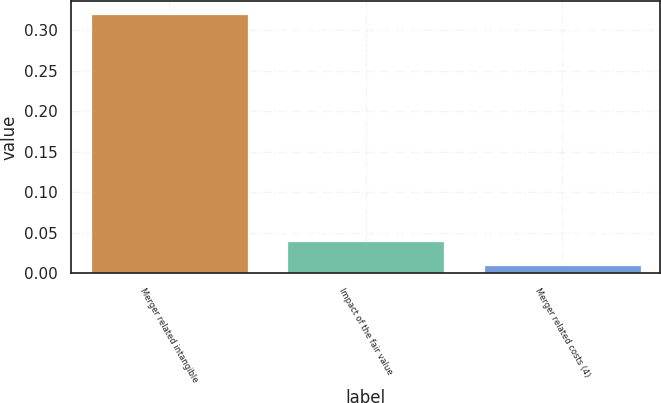<chart> <loc_0><loc_0><loc_500><loc_500><bar_chart><fcel>Merger related intangible<fcel>Impact of the fair value<fcel>Merger related costs (4)<nl><fcel>0.32<fcel>0.04<fcel>0.01<nl></chart> 